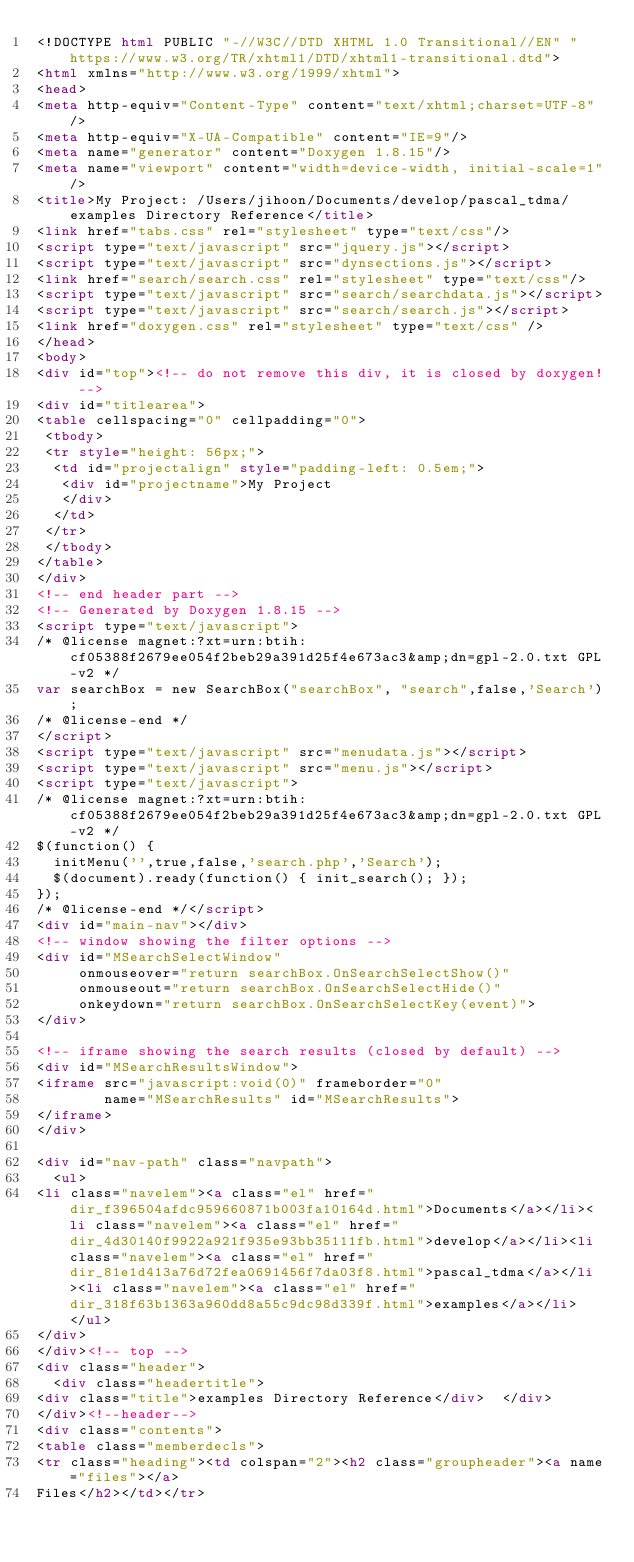<code> <loc_0><loc_0><loc_500><loc_500><_HTML_><!DOCTYPE html PUBLIC "-//W3C//DTD XHTML 1.0 Transitional//EN" "https://www.w3.org/TR/xhtml1/DTD/xhtml1-transitional.dtd">
<html xmlns="http://www.w3.org/1999/xhtml">
<head>
<meta http-equiv="Content-Type" content="text/xhtml;charset=UTF-8"/>
<meta http-equiv="X-UA-Compatible" content="IE=9"/>
<meta name="generator" content="Doxygen 1.8.15"/>
<meta name="viewport" content="width=device-width, initial-scale=1"/>
<title>My Project: /Users/jihoon/Documents/develop/pascal_tdma/examples Directory Reference</title>
<link href="tabs.css" rel="stylesheet" type="text/css"/>
<script type="text/javascript" src="jquery.js"></script>
<script type="text/javascript" src="dynsections.js"></script>
<link href="search/search.css" rel="stylesheet" type="text/css"/>
<script type="text/javascript" src="search/searchdata.js"></script>
<script type="text/javascript" src="search/search.js"></script>
<link href="doxygen.css" rel="stylesheet" type="text/css" />
</head>
<body>
<div id="top"><!-- do not remove this div, it is closed by doxygen! -->
<div id="titlearea">
<table cellspacing="0" cellpadding="0">
 <tbody>
 <tr style="height: 56px;">
  <td id="projectalign" style="padding-left: 0.5em;">
   <div id="projectname">My Project
   </div>
  </td>
 </tr>
 </tbody>
</table>
</div>
<!-- end header part -->
<!-- Generated by Doxygen 1.8.15 -->
<script type="text/javascript">
/* @license magnet:?xt=urn:btih:cf05388f2679ee054f2beb29a391d25f4e673ac3&amp;dn=gpl-2.0.txt GPL-v2 */
var searchBox = new SearchBox("searchBox", "search",false,'Search');
/* @license-end */
</script>
<script type="text/javascript" src="menudata.js"></script>
<script type="text/javascript" src="menu.js"></script>
<script type="text/javascript">
/* @license magnet:?xt=urn:btih:cf05388f2679ee054f2beb29a391d25f4e673ac3&amp;dn=gpl-2.0.txt GPL-v2 */
$(function() {
  initMenu('',true,false,'search.php','Search');
  $(document).ready(function() { init_search(); });
});
/* @license-end */</script>
<div id="main-nav"></div>
<!-- window showing the filter options -->
<div id="MSearchSelectWindow"
     onmouseover="return searchBox.OnSearchSelectShow()"
     onmouseout="return searchBox.OnSearchSelectHide()"
     onkeydown="return searchBox.OnSearchSelectKey(event)">
</div>

<!-- iframe showing the search results (closed by default) -->
<div id="MSearchResultsWindow">
<iframe src="javascript:void(0)" frameborder="0" 
        name="MSearchResults" id="MSearchResults">
</iframe>
</div>

<div id="nav-path" class="navpath">
  <ul>
<li class="navelem"><a class="el" href="dir_f396504afdc959660871b003fa10164d.html">Documents</a></li><li class="navelem"><a class="el" href="dir_4d30140f9922a921f935e93bb35111fb.html">develop</a></li><li class="navelem"><a class="el" href="dir_81e1d413a76d72fea0691456f7da03f8.html">pascal_tdma</a></li><li class="navelem"><a class="el" href="dir_318f63b1363a960dd8a55c9dc98d339f.html">examples</a></li>  </ul>
</div>
</div><!-- top -->
<div class="header">
  <div class="headertitle">
<div class="title">examples Directory Reference</div>  </div>
</div><!--header-->
<div class="contents">
<table class="memberdecls">
<tr class="heading"><td colspan="2"><h2 class="groupheader"><a name="files"></a>
Files</h2></td></tr></code> 